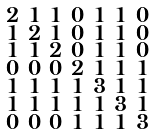Convert formula to latex. <formula><loc_0><loc_0><loc_500><loc_500>\begin{smallmatrix} 2 & 1 & 1 & 0 & 1 & 1 & 0 \\ 1 & 2 & 1 & 0 & 1 & 1 & 0 \\ 1 & 1 & 2 & 0 & 1 & 1 & 0 \\ 0 & 0 & 0 & 2 & 1 & 1 & 1 \\ 1 & 1 & 1 & 1 & 3 & 1 & 1 \\ 1 & 1 & 1 & 1 & 1 & 3 & 1 \\ 0 & 0 & 0 & 1 & 1 & 1 & 3 \end{smallmatrix}</formula> 